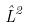<formula> <loc_0><loc_0><loc_500><loc_500>\hat { L } ^ { 2 }</formula> 